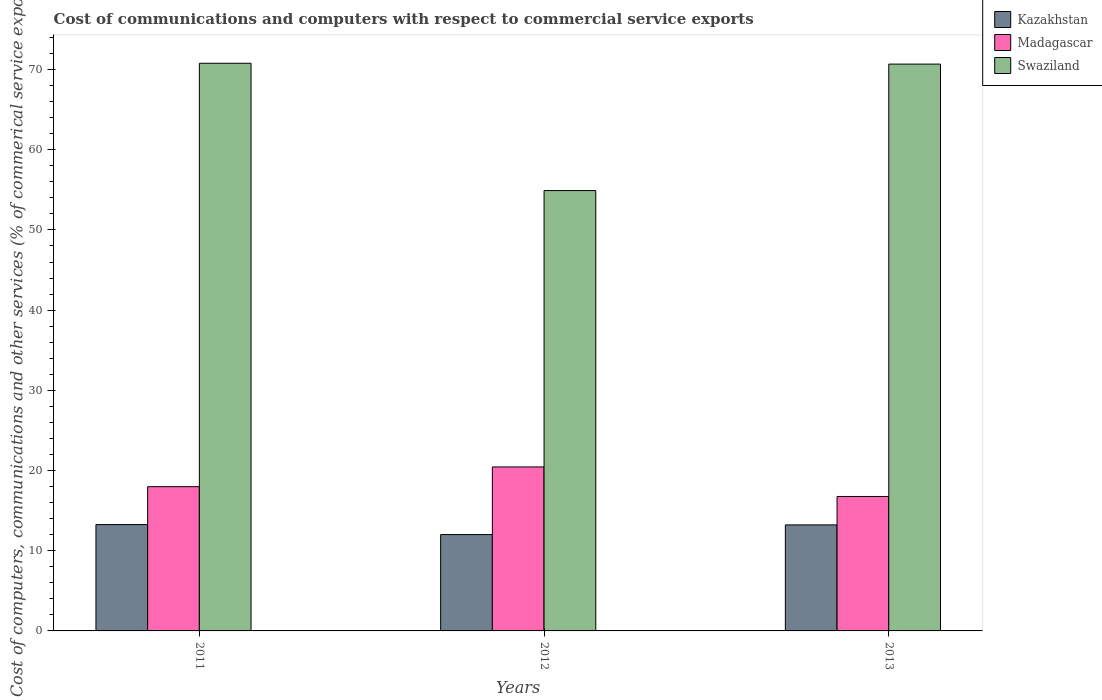Are the number of bars per tick equal to the number of legend labels?
Provide a succinct answer. Yes. How many bars are there on the 3rd tick from the left?
Your response must be concise. 3. How many bars are there on the 1st tick from the right?
Your response must be concise. 3. What is the label of the 2nd group of bars from the left?
Your response must be concise. 2012. In how many cases, is the number of bars for a given year not equal to the number of legend labels?
Keep it short and to the point. 0. What is the cost of communications and computers in Kazakhstan in 2011?
Keep it short and to the point. 13.26. Across all years, what is the maximum cost of communications and computers in Kazakhstan?
Your answer should be compact. 13.26. Across all years, what is the minimum cost of communications and computers in Kazakhstan?
Provide a succinct answer. 12.02. In which year was the cost of communications and computers in Swaziland maximum?
Keep it short and to the point. 2011. What is the total cost of communications and computers in Kazakhstan in the graph?
Offer a terse response. 38.49. What is the difference between the cost of communications and computers in Swaziland in 2012 and that in 2013?
Your answer should be compact. -15.77. What is the difference between the cost of communications and computers in Kazakhstan in 2011 and the cost of communications and computers in Swaziland in 2013?
Offer a terse response. -57.42. What is the average cost of communications and computers in Kazakhstan per year?
Provide a short and direct response. 12.83. In the year 2013, what is the difference between the cost of communications and computers in Swaziland and cost of communications and computers in Madagascar?
Provide a succinct answer. 53.91. What is the ratio of the cost of communications and computers in Kazakhstan in 2012 to that in 2013?
Offer a terse response. 0.91. Is the cost of communications and computers in Swaziland in 2011 less than that in 2012?
Your answer should be very brief. No. What is the difference between the highest and the second highest cost of communications and computers in Swaziland?
Your answer should be compact. 0.11. What is the difference between the highest and the lowest cost of communications and computers in Madagascar?
Keep it short and to the point. 3.68. Is the sum of the cost of communications and computers in Swaziland in 2012 and 2013 greater than the maximum cost of communications and computers in Madagascar across all years?
Your answer should be compact. Yes. What does the 2nd bar from the left in 2011 represents?
Keep it short and to the point. Madagascar. What does the 2nd bar from the right in 2012 represents?
Keep it short and to the point. Madagascar. Is it the case that in every year, the sum of the cost of communications and computers in Kazakhstan and cost of communications and computers in Swaziland is greater than the cost of communications and computers in Madagascar?
Your response must be concise. Yes. How many bars are there?
Your response must be concise. 9. Are all the bars in the graph horizontal?
Keep it short and to the point. No. How many years are there in the graph?
Your answer should be very brief. 3. What is the difference between two consecutive major ticks on the Y-axis?
Offer a very short reply. 10. Are the values on the major ticks of Y-axis written in scientific E-notation?
Provide a succinct answer. No. Does the graph contain any zero values?
Ensure brevity in your answer.  No. Does the graph contain grids?
Provide a succinct answer. No. How many legend labels are there?
Your answer should be very brief. 3. What is the title of the graph?
Make the answer very short. Cost of communications and computers with respect to commercial service exports. Does "Kenya" appear as one of the legend labels in the graph?
Give a very brief answer. No. What is the label or title of the X-axis?
Your answer should be compact. Years. What is the label or title of the Y-axis?
Give a very brief answer. Cost of computers, communications and other services (% of commerical service exports). What is the Cost of computers, communications and other services (% of commerical service exports) of Kazakhstan in 2011?
Give a very brief answer. 13.26. What is the Cost of computers, communications and other services (% of commerical service exports) in Madagascar in 2011?
Offer a terse response. 17.99. What is the Cost of computers, communications and other services (% of commerical service exports) in Swaziland in 2011?
Make the answer very short. 70.79. What is the Cost of computers, communications and other services (% of commerical service exports) in Kazakhstan in 2012?
Your answer should be very brief. 12.02. What is the Cost of computers, communications and other services (% of commerical service exports) in Madagascar in 2012?
Offer a terse response. 20.45. What is the Cost of computers, communications and other services (% of commerical service exports) of Swaziland in 2012?
Keep it short and to the point. 54.91. What is the Cost of computers, communications and other services (% of commerical service exports) in Kazakhstan in 2013?
Give a very brief answer. 13.22. What is the Cost of computers, communications and other services (% of commerical service exports) of Madagascar in 2013?
Your answer should be compact. 16.77. What is the Cost of computers, communications and other services (% of commerical service exports) in Swaziland in 2013?
Ensure brevity in your answer.  70.68. Across all years, what is the maximum Cost of computers, communications and other services (% of commerical service exports) of Kazakhstan?
Keep it short and to the point. 13.26. Across all years, what is the maximum Cost of computers, communications and other services (% of commerical service exports) of Madagascar?
Make the answer very short. 20.45. Across all years, what is the maximum Cost of computers, communications and other services (% of commerical service exports) in Swaziland?
Ensure brevity in your answer.  70.79. Across all years, what is the minimum Cost of computers, communications and other services (% of commerical service exports) in Kazakhstan?
Your answer should be compact. 12.02. Across all years, what is the minimum Cost of computers, communications and other services (% of commerical service exports) in Madagascar?
Your response must be concise. 16.77. Across all years, what is the minimum Cost of computers, communications and other services (% of commerical service exports) of Swaziland?
Give a very brief answer. 54.91. What is the total Cost of computers, communications and other services (% of commerical service exports) in Kazakhstan in the graph?
Provide a succinct answer. 38.49. What is the total Cost of computers, communications and other services (% of commerical service exports) of Madagascar in the graph?
Offer a very short reply. 55.2. What is the total Cost of computers, communications and other services (% of commerical service exports) in Swaziland in the graph?
Give a very brief answer. 196.37. What is the difference between the Cost of computers, communications and other services (% of commerical service exports) in Kazakhstan in 2011 and that in 2012?
Your response must be concise. 1.24. What is the difference between the Cost of computers, communications and other services (% of commerical service exports) of Madagascar in 2011 and that in 2012?
Your answer should be compact. -2.46. What is the difference between the Cost of computers, communications and other services (% of commerical service exports) in Swaziland in 2011 and that in 2012?
Offer a very short reply. 15.88. What is the difference between the Cost of computers, communications and other services (% of commerical service exports) in Kazakhstan in 2011 and that in 2013?
Your answer should be very brief. 0.04. What is the difference between the Cost of computers, communications and other services (% of commerical service exports) in Madagascar in 2011 and that in 2013?
Give a very brief answer. 1.22. What is the difference between the Cost of computers, communications and other services (% of commerical service exports) in Swaziland in 2011 and that in 2013?
Provide a short and direct response. 0.11. What is the difference between the Cost of computers, communications and other services (% of commerical service exports) in Kazakhstan in 2012 and that in 2013?
Keep it short and to the point. -1.2. What is the difference between the Cost of computers, communications and other services (% of commerical service exports) in Madagascar in 2012 and that in 2013?
Keep it short and to the point. 3.68. What is the difference between the Cost of computers, communications and other services (% of commerical service exports) of Swaziland in 2012 and that in 2013?
Make the answer very short. -15.77. What is the difference between the Cost of computers, communications and other services (% of commerical service exports) of Kazakhstan in 2011 and the Cost of computers, communications and other services (% of commerical service exports) of Madagascar in 2012?
Make the answer very short. -7.19. What is the difference between the Cost of computers, communications and other services (% of commerical service exports) of Kazakhstan in 2011 and the Cost of computers, communications and other services (% of commerical service exports) of Swaziland in 2012?
Offer a very short reply. -41.65. What is the difference between the Cost of computers, communications and other services (% of commerical service exports) of Madagascar in 2011 and the Cost of computers, communications and other services (% of commerical service exports) of Swaziland in 2012?
Keep it short and to the point. -36.92. What is the difference between the Cost of computers, communications and other services (% of commerical service exports) of Kazakhstan in 2011 and the Cost of computers, communications and other services (% of commerical service exports) of Madagascar in 2013?
Give a very brief answer. -3.51. What is the difference between the Cost of computers, communications and other services (% of commerical service exports) in Kazakhstan in 2011 and the Cost of computers, communications and other services (% of commerical service exports) in Swaziland in 2013?
Provide a short and direct response. -57.42. What is the difference between the Cost of computers, communications and other services (% of commerical service exports) in Madagascar in 2011 and the Cost of computers, communications and other services (% of commerical service exports) in Swaziland in 2013?
Make the answer very short. -52.69. What is the difference between the Cost of computers, communications and other services (% of commerical service exports) of Kazakhstan in 2012 and the Cost of computers, communications and other services (% of commerical service exports) of Madagascar in 2013?
Give a very brief answer. -4.75. What is the difference between the Cost of computers, communications and other services (% of commerical service exports) in Kazakhstan in 2012 and the Cost of computers, communications and other services (% of commerical service exports) in Swaziland in 2013?
Your answer should be very brief. -58.66. What is the difference between the Cost of computers, communications and other services (% of commerical service exports) of Madagascar in 2012 and the Cost of computers, communications and other services (% of commerical service exports) of Swaziland in 2013?
Offer a terse response. -50.23. What is the average Cost of computers, communications and other services (% of commerical service exports) in Kazakhstan per year?
Your response must be concise. 12.83. What is the average Cost of computers, communications and other services (% of commerical service exports) in Madagascar per year?
Your response must be concise. 18.4. What is the average Cost of computers, communications and other services (% of commerical service exports) of Swaziland per year?
Provide a succinct answer. 65.46. In the year 2011, what is the difference between the Cost of computers, communications and other services (% of commerical service exports) in Kazakhstan and Cost of computers, communications and other services (% of commerical service exports) in Madagascar?
Ensure brevity in your answer.  -4.73. In the year 2011, what is the difference between the Cost of computers, communications and other services (% of commerical service exports) of Kazakhstan and Cost of computers, communications and other services (% of commerical service exports) of Swaziland?
Your answer should be compact. -57.53. In the year 2011, what is the difference between the Cost of computers, communications and other services (% of commerical service exports) of Madagascar and Cost of computers, communications and other services (% of commerical service exports) of Swaziland?
Your answer should be very brief. -52.8. In the year 2012, what is the difference between the Cost of computers, communications and other services (% of commerical service exports) in Kazakhstan and Cost of computers, communications and other services (% of commerical service exports) in Madagascar?
Provide a short and direct response. -8.43. In the year 2012, what is the difference between the Cost of computers, communications and other services (% of commerical service exports) in Kazakhstan and Cost of computers, communications and other services (% of commerical service exports) in Swaziland?
Give a very brief answer. -42.89. In the year 2012, what is the difference between the Cost of computers, communications and other services (% of commerical service exports) of Madagascar and Cost of computers, communications and other services (% of commerical service exports) of Swaziland?
Keep it short and to the point. -34.46. In the year 2013, what is the difference between the Cost of computers, communications and other services (% of commerical service exports) in Kazakhstan and Cost of computers, communications and other services (% of commerical service exports) in Madagascar?
Keep it short and to the point. -3.55. In the year 2013, what is the difference between the Cost of computers, communications and other services (% of commerical service exports) in Kazakhstan and Cost of computers, communications and other services (% of commerical service exports) in Swaziland?
Your answer should be compact. -57.46. In the year 2013, what is the difference between the Cost of computers, communications and other services (% of commerical service exports) of Madagascar and Cost of computers, communications and other services (% of commerical service exports) of Swaziland?
Your answer should be compact. -53.91. What is the ratio of the Cost of computers, communications and other services (% of commerical service exports) of Kazakhstan in 2011 to that in 2012?
Offer a terse response. 1.1. What is the ratio of the Cost of computers, communications and other services (% of commerical service exports) in Madagascar in 2011 to that in 2012?
Give a very brief answer. 0.88. What is the ratio of the Cost of computers, communications and other services (% of commerical service exports) in Swaziland in 2011 to that in 2012?
Ensure brevity in your answer.  1.29. What is the ratio of the Cost of computers, communications and other services (% of commerical service exports) of Madagascar in 2011 to that in 2013?
Offer a terse response. 1.07. What is the ratio of the Cost of computers, communications and other services (% of commerical service exports) in Swaziland in 2011 to that in 2013?
Offer a very short reply. 1. What is the ratio of the Cost of computers, communications and other services (% of commerical service exports) of Kazakhstan in 2012 to that in 2013?
Offer a terse response. 0.91. What is the ratio of the Cost of computers, communications and other services (% of commerical service exports) in Madagascar in 2012 to that in 2013?
Offer a very short reply. 1.22. What is the ratio of the Cost of computers, communications and other services (% of commerical service exports) of Swaziland in 2012 to that in 2013?
Your answer should be very brief. 0.78. What is the difference between the highest and the second highest Cost of computers, communications and other services (% of commerical service exports) of Kazakhstan?
Offer a terse response. 0.04. What is the difference between the highest and the second highest Cost of computers, communications and other services (% of commerical service exports) of Madagascar?
Make the answer very short. 2.46. What is the difference between the highest and the second highest Cost of computers, communications and other services (% of commerical service exports) in Swaziland?
Make the answer very short. 0.11. What is the difference between the highest and the lowest Cost of computers, communications and other services (% of commerical service exports) in Kazakhstan?
Provide a short and direct response. 1.24. What is the difference between the highest and the lowest Cost of computers, communications and other services (% of commerical service exports) of Madagascar?
Offer a terse response. 3.68. What is the difference between the highest and the lowest Cost of computers, communications and other services (% of commerical service exports) in Swaziland?
Keep it short and to the point. 15.88. 